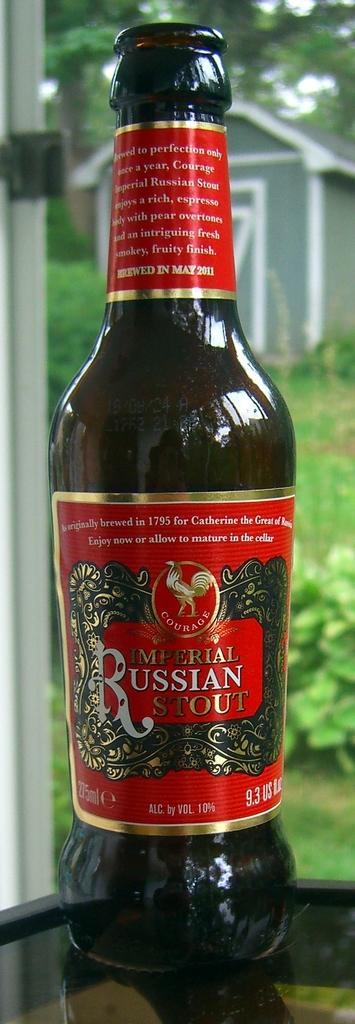Provide a one-sentence caption for the provided image. a close up of Imperial Russian Stout by a window. 